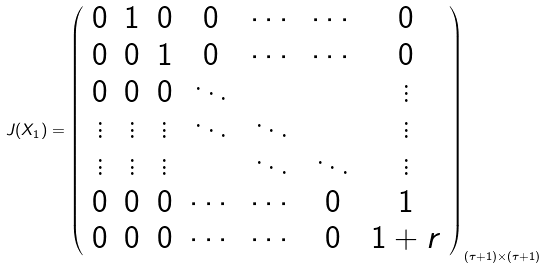Convert formula to latex. <formula><loc_0><loc_0><loc_500><loc_500>J ( X _ { 1 } ) = \left ( \begin{array} { c c c c c c c } 0 & 1 & 0 & 0 & \cdots & \cdots & 0 \\ 0 & 0 & 1 & 0 & \cdots & \cdots & 0 \\ 0 & 0 & 0 & \ddots & & & \vdots \\ \vdots & \vdots & \vdots & \ddots & \ddots & & \vdots \\ \vdots & \vdots & \vdots & & \ddots & \ddots & \vdots \\ 0 & 0 & 0 & \cdots & \cdots & 0 & 1 \\ 0 & 0 & 0 & \cdots & \cdots & 0 & 1 + r \\ \end{array} \right ) _ { ( \tau + 1 ) \times ( \tau + 1 ) }</formula> 